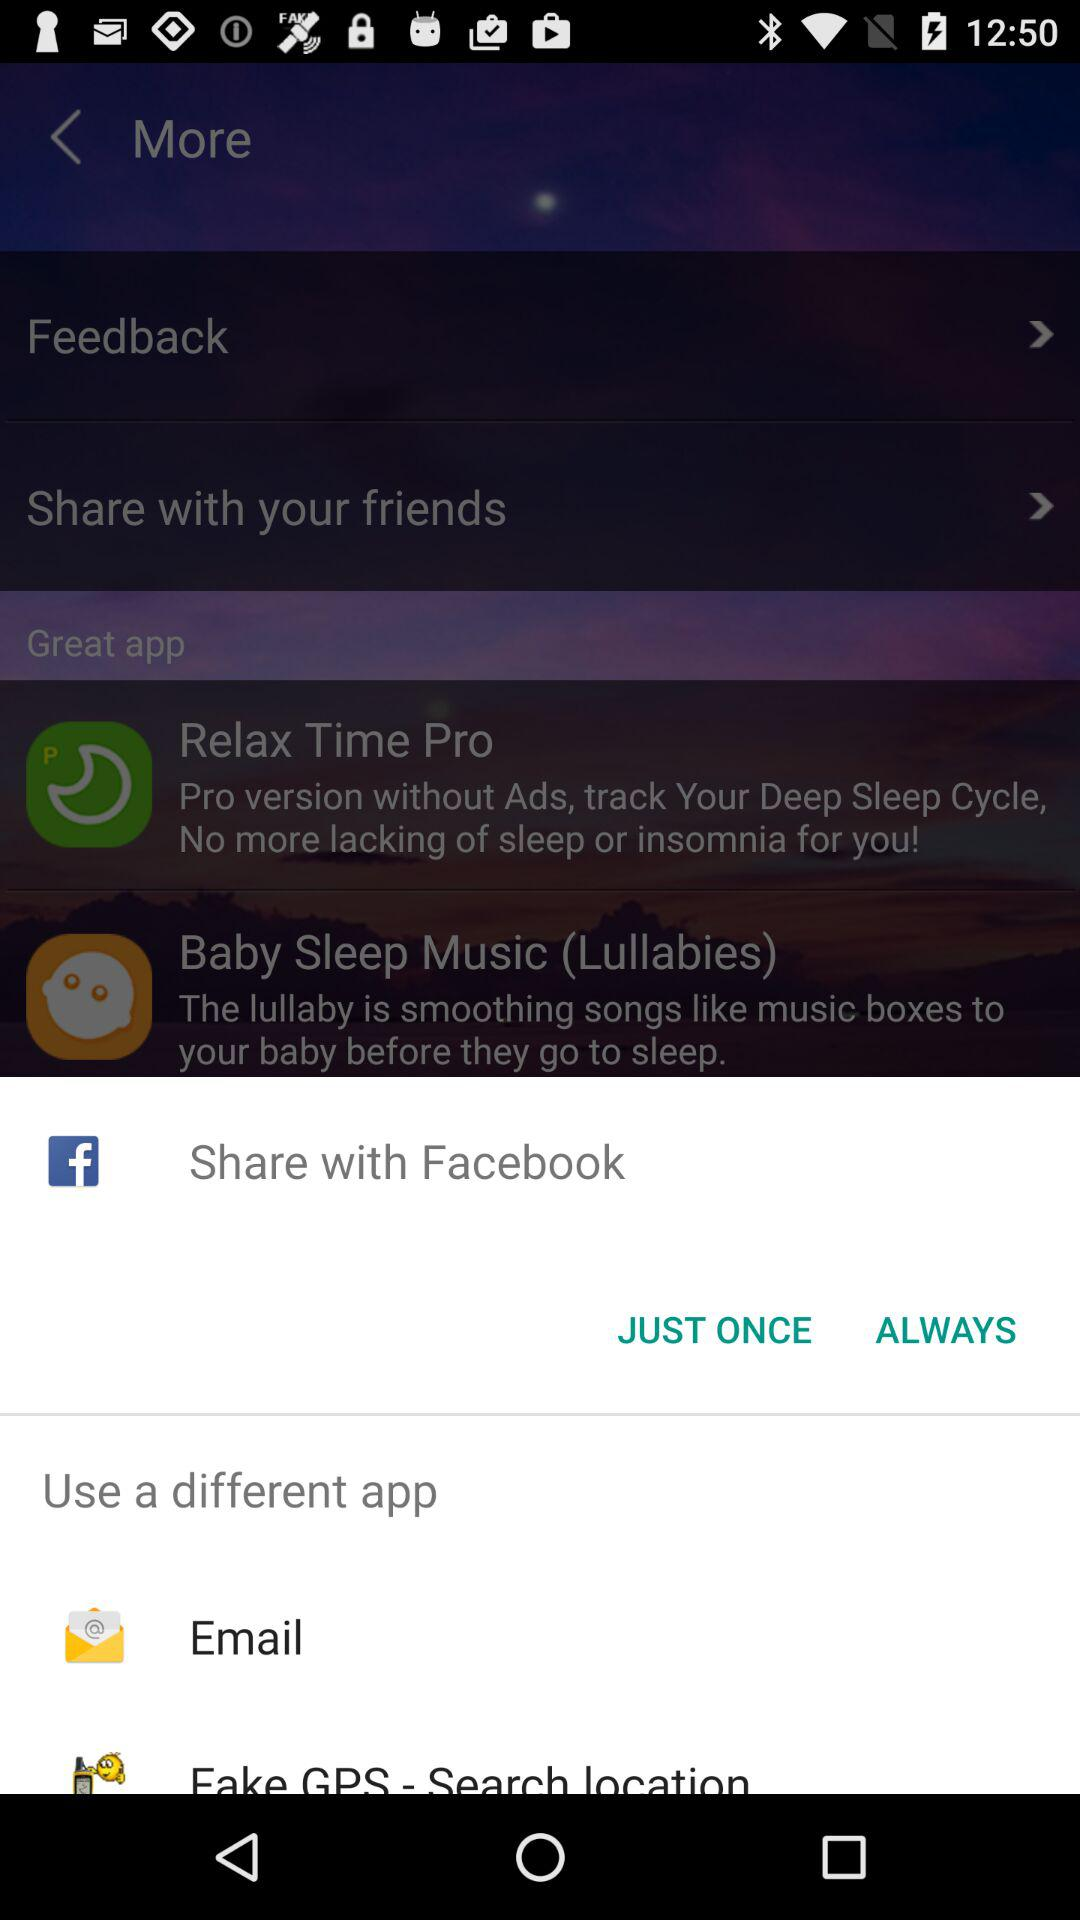How many items have a forward arrow?
Answer the question using a single word or phrase. 2 